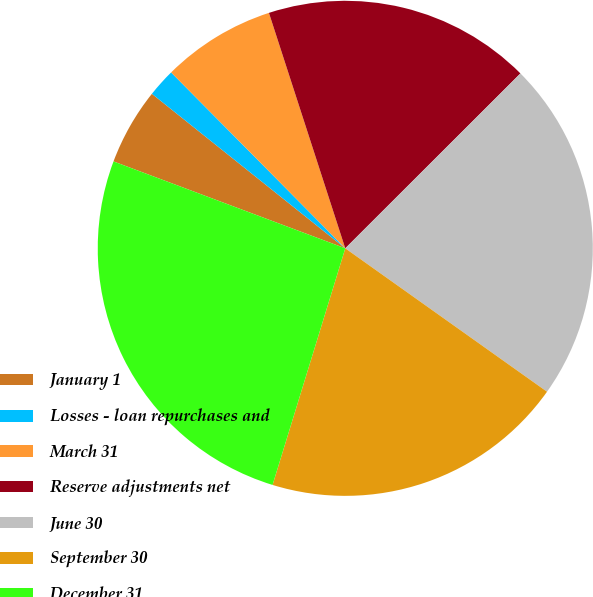<chart> <loc_0><loc_0><loc_500><loc_500><pie_chart><fcel>January 1<fcel>Losses - loan repurchases and<fcel>March 31<fcel>Reserve adjustments net<fcel>June 30<fcel>September 30<fcel>December 31<nl><fcel>5.02%<fcel>1.85%<fcel>7.43%<fcel>17.5%<fcel>22.32%<fcel>19.91%<fcel>25.96%<nl></chart> 